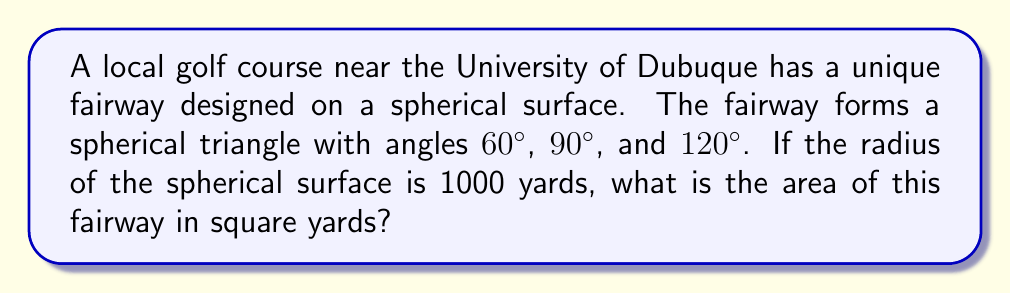What is the answer to this math problem? To solve this problem, we'll use the formula for the area of a spherical triangle on a unit sphere and then scale it to our given radius. Here's the step-by-step solution:

1) The formula for the area of a spherical triangle on a unit sphere is:

   $$A = (\alpha + \beta + \gamma - \pi)$$

   where $\alpha$, $\beta$, and $\gamma$ are the angles of the triangle in radians, and $A$ is in steradians.

2) Convert our angles from degrees to radians:
   $60° = \frac{\pi}{3}$
   $90° = \frac{\pi}{2}$
   $120° = \frac{2\pi}{3}$

3) Substitute these values into our formula:

   $$A = (\frac{\pi}{3} + \frac{\pi}{2} + \frac{2\pi}{3} - \pi) = \frac{\pi}{2}$$

4) This gives us the area on a unit sphere. To get the area on our sphere with radius $r = 1000$ yards, we multiply by $r^2$:

   $$A_{1000} = \frac{\pi}{2} \cdot 1000^2 = 500000\pi$$

5) Convert this to square yards:

   $$A_{sq.yards} = 500000\pi \approx 1570796.33$$
Answer: $1,570,796.33$ square yards 